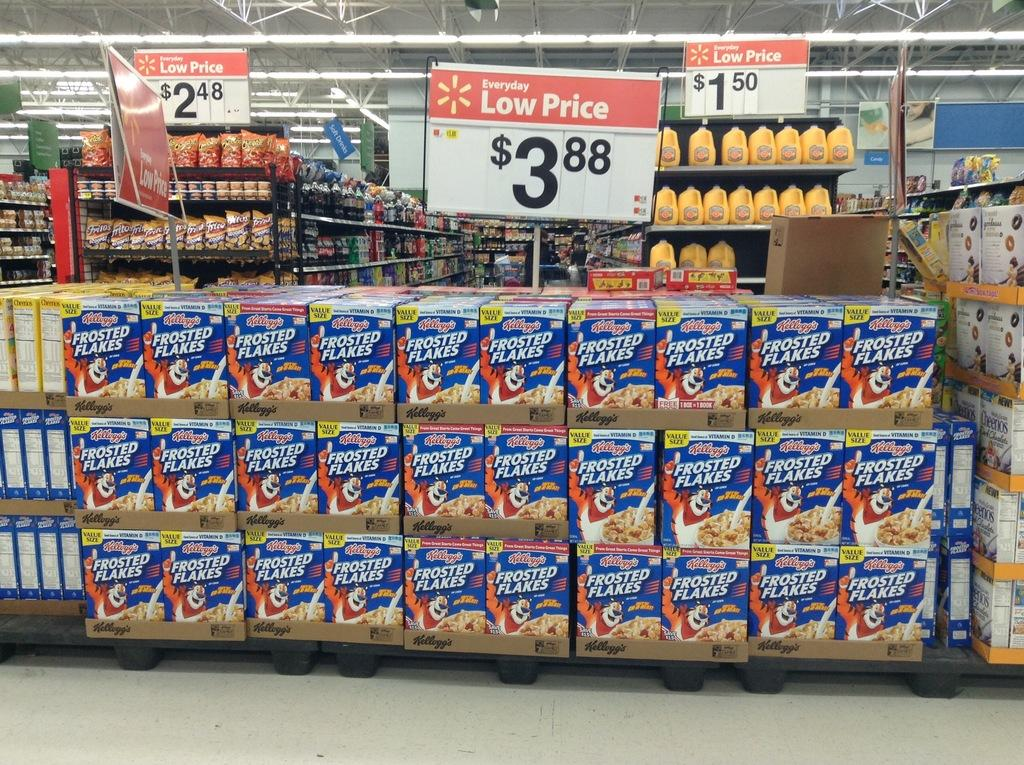<image>
Provide a brief description of the given image. A display of frosted flakes priced at 3 dollars and 88 cents. 